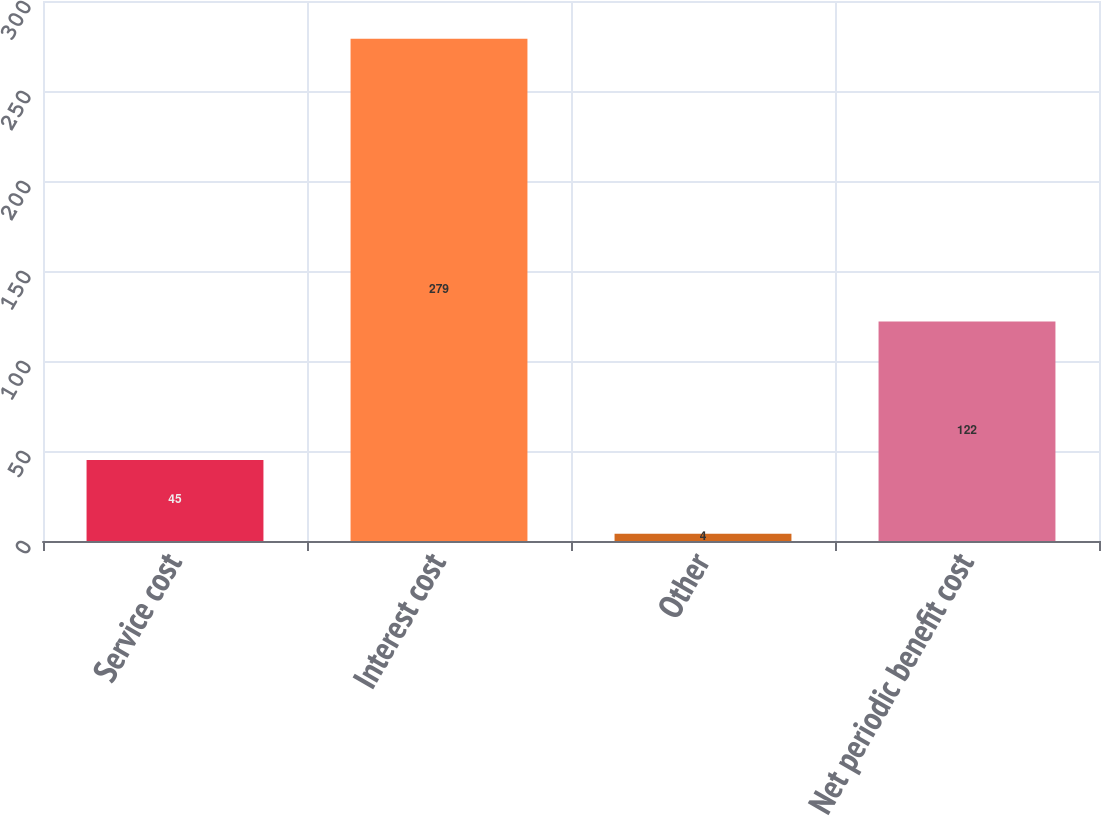Convert chart. <chart><loc_0><loc_0><loc_500><loc_500><bar_chart><fcel>Service cost<fcel>Interest cost<fcel>Other<fcel>Net periodic benefit cost<nl><fcel>45<fcel>279<fcel>4<fcel>122<nl></chart> 